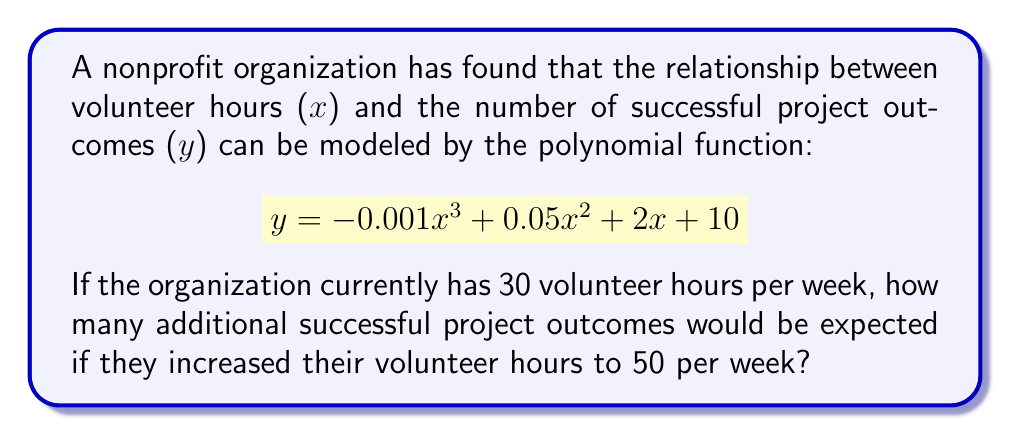Help me with this question. To solve this problem, we need to:

1. Calculate the number of successful project outcomes for 30 volunteer hours
2. Calculate the number of successful project outcomes for 50 volunteer hours
3. Find the difference between these two values

Step 1: Calculate y for x = 30
$$\begin{align*}
y &= -0.001(30)^3 + 0.05(30)^2 + 2(30) + 10 \\
&= -0.001(27000) + 0.05(900) + 60 + 10 \\
&= -27 + 45 + 60 + 10 \\
&= 88
\end{align*}$$

Step 2: Calculate y for x = 50
$$\begin{align*}
y &= -0.001(50)^3 + 0.05(50)^2 + 2(50) + 10 \\
&= -0.001(125000) + 0.05(2500) + 100 + 10 \\
&= -125 + 125 + 100 + 10 \\
&= 110
\end{align*}$$

Step 3: Find the difference
Additional successful project outcomes = 110 - 88 = 22
Answer: The organization would expect 22 additional successful project outcomes by increasing their volunteer hours from 30 to 50 per week. 